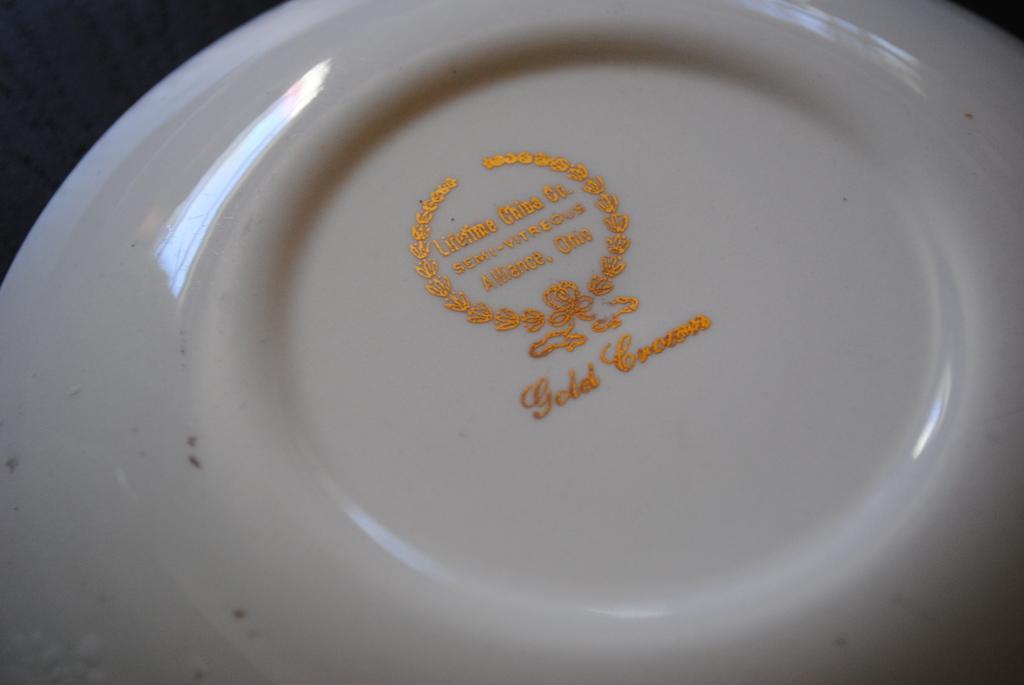Please provide a concise description of this image. In this image I can see a plate which is white in color on the black colored surface and on the plate I can see something is printed with gold color. 